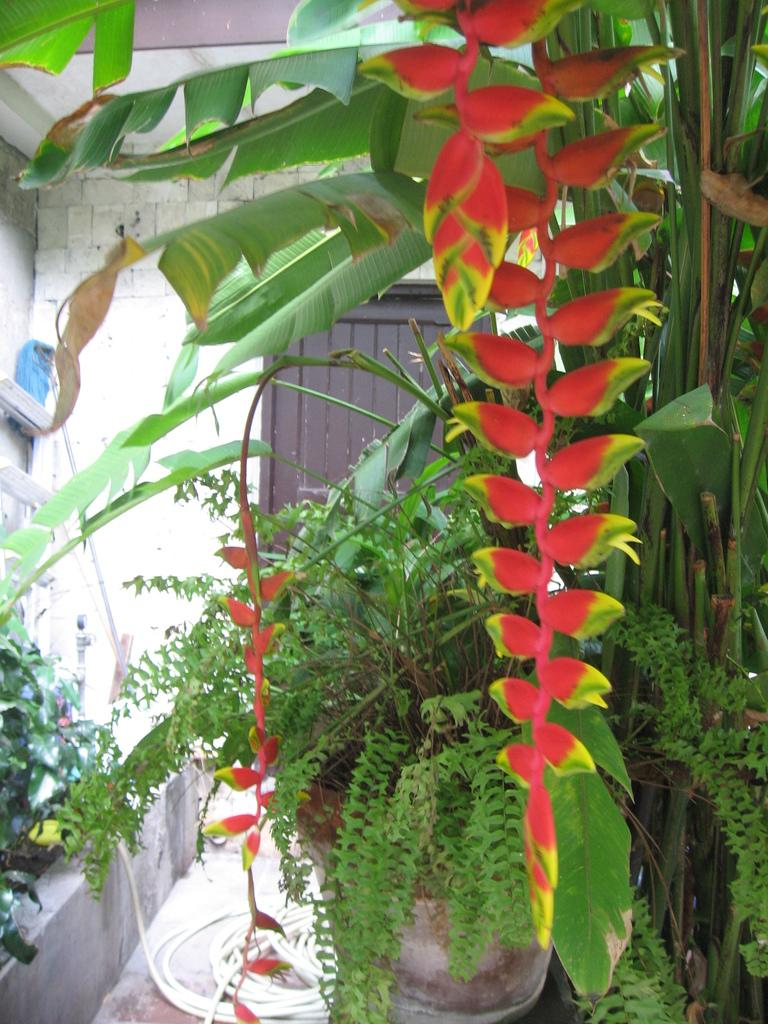What is located in the front of the image? There are plants in the front of the image. What object can be seen on the ground in the image? There is a pipe on the ground in the image. What structure is visible in the background of the image? There is a door in the background of the image. What else can be seen in the background of the image? There is a wall in the background of the image. What type of sponge is floating in space in the image? There is no sponge or space present in the image. What kind of meal is being prepared in the background of the image? There is no meal preparation visible in the image; it only features plants, a pipe, a door, and a wall. 